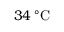Convert formula to latex. <formula><loc_0><loc_0><loc_500><loc_500>3 4 \, ^ { \circ } C</formula> 